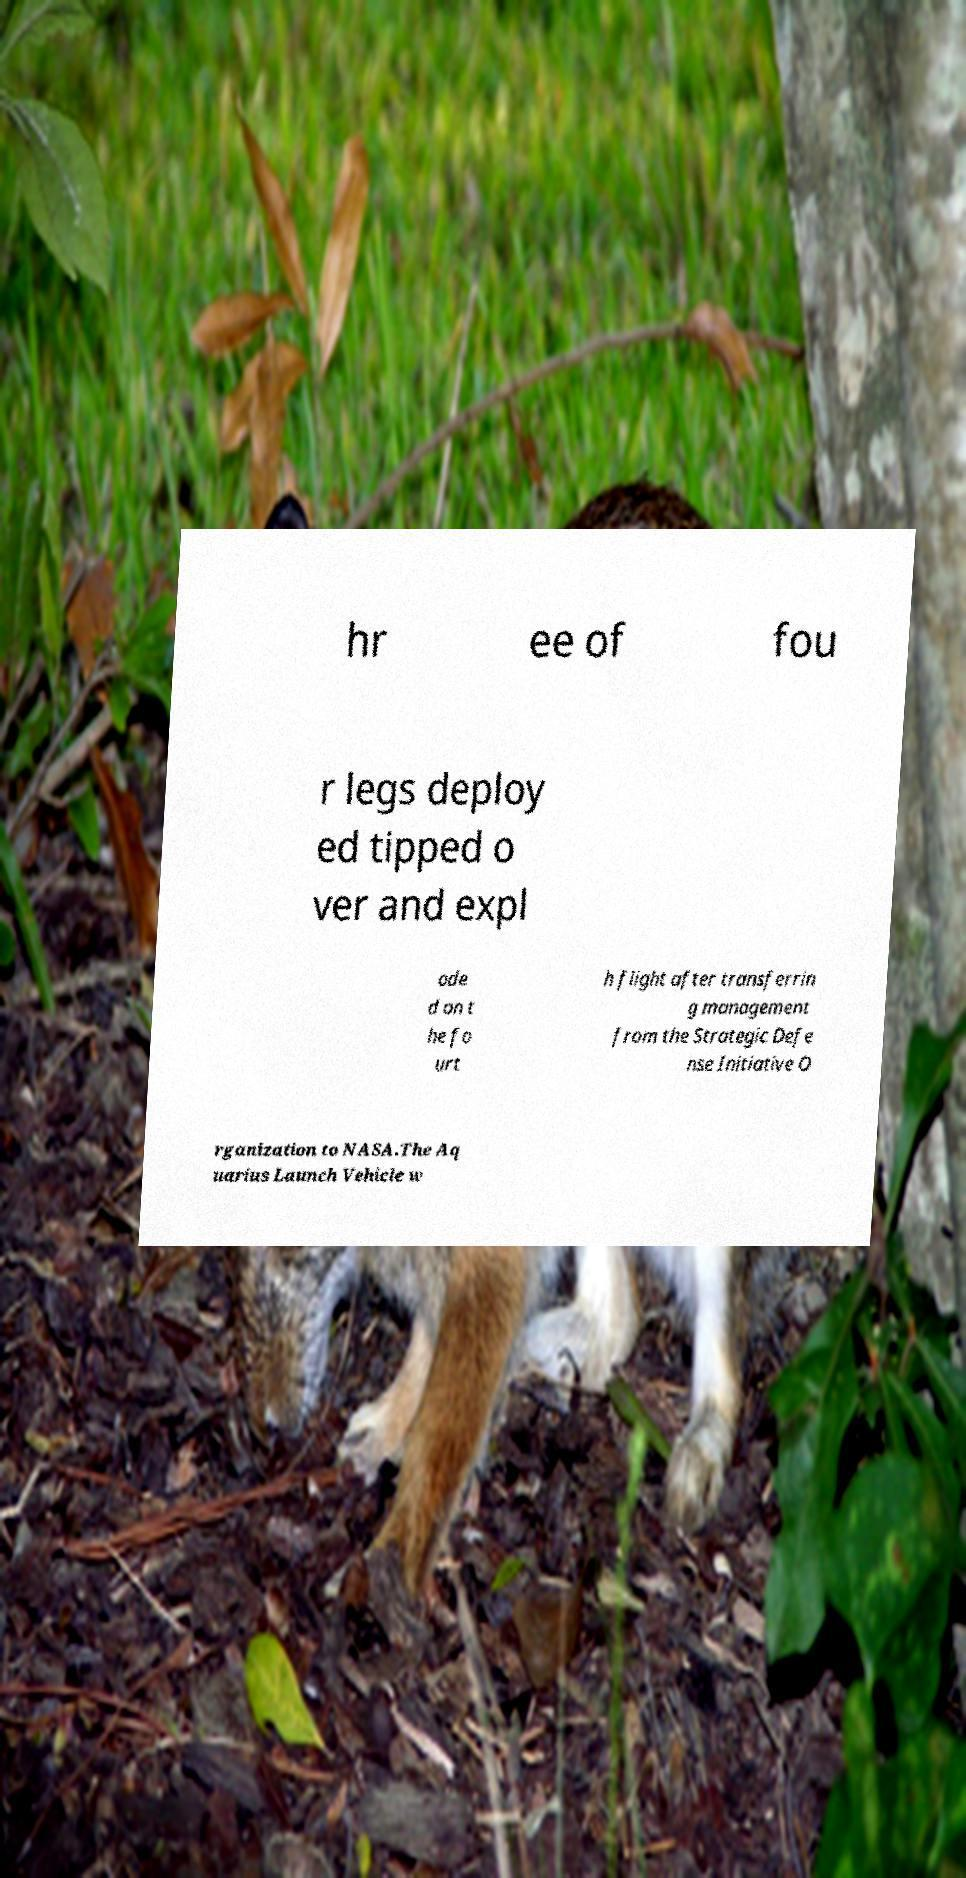Can you accurately transcribe the text from the provided image for me? hr ee of fou r legs deploy ed tipped o ver and expl ode d on t he fo urt h flight after transferrin g management from the Strategic Defe nse Initiative O rganization to NASA.The Aq uarius Launch Vehicle w 